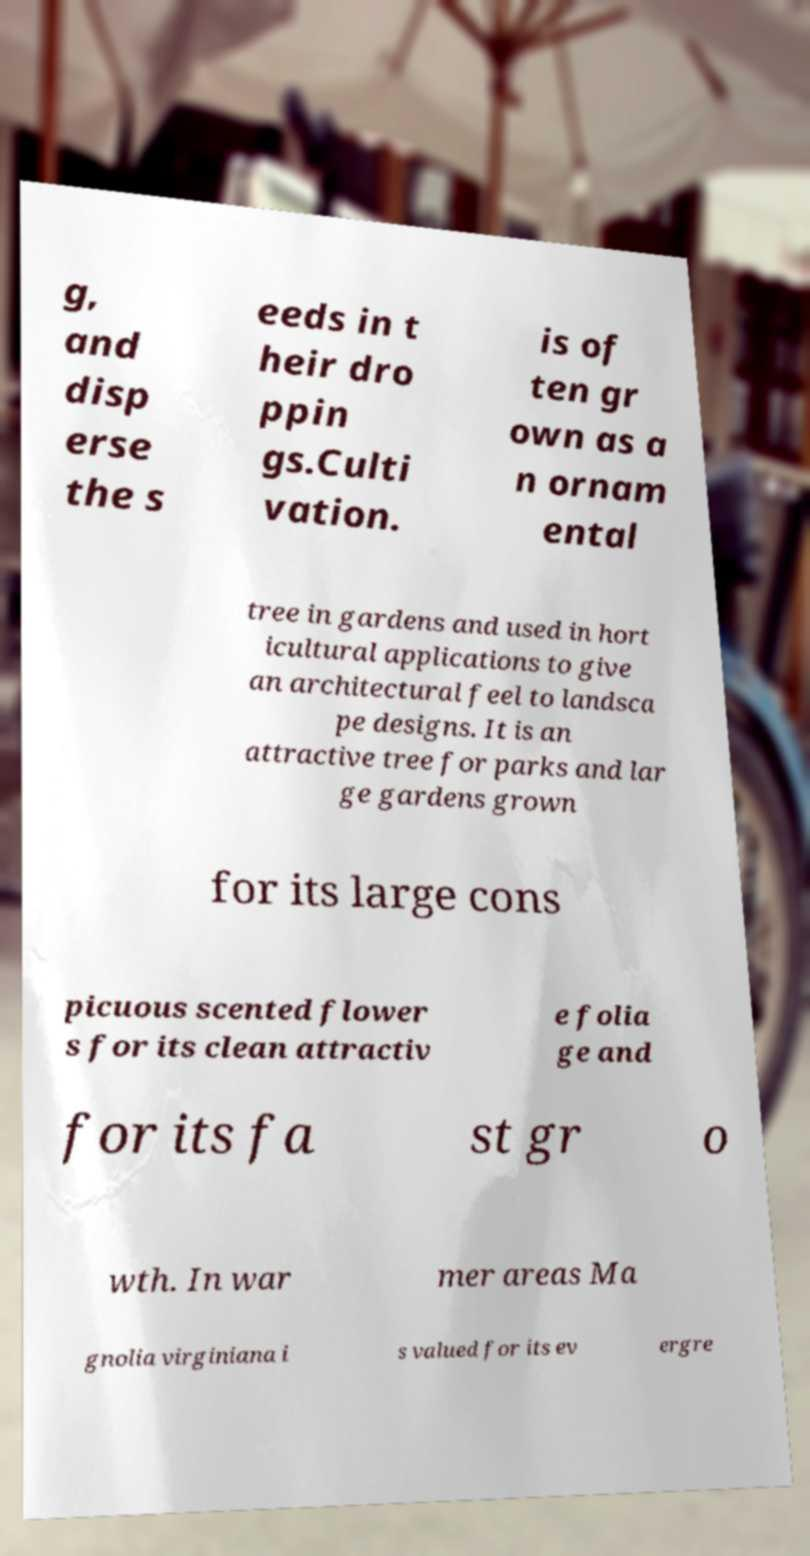For documentation purposes, I need the text within this image transcribed. Could you provide that? g, and disp erse the s eeds in t heir dro ppin gs.Culti vation. is of ten gr own as a n ornam ental tree in gardens and used in hort icultural applications to give an architectural feel to landsca pe designs. It is an attractive tree for parks and lar ge gardens grown for its large cons picuous scented flower s for its clean attractiv e folia ge and for its fa st gr o wth. In war mer areas Ma gnolia virginiana i s valued for its ev ergre 